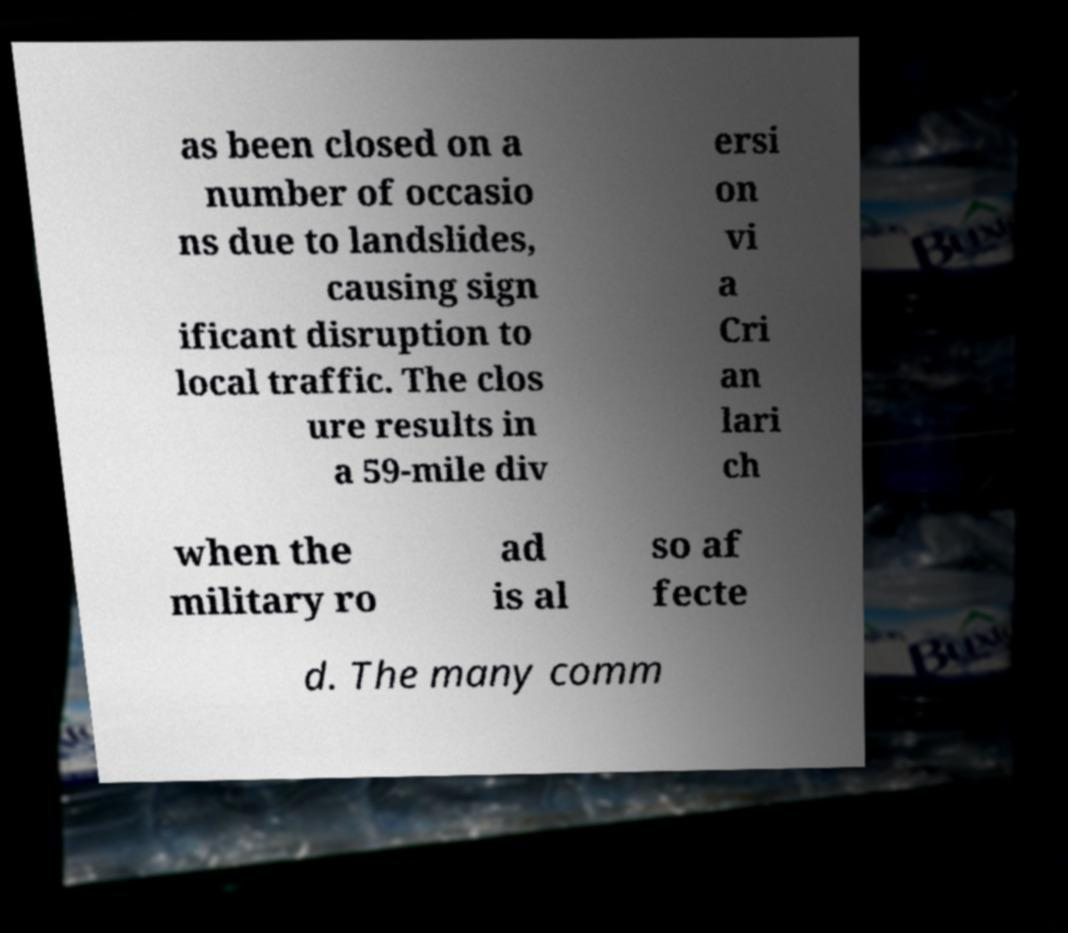For documentation purposes, I need the text within this image transcribed. Could you provide that? as been closed on a number of occasio ns due to landslides, causing sign ificant disruption to local traffic. The clos ure results in a 59-mile div ersi on vi a Cri an lari ch when the military ro ad is al so af fecte d. The many comm 